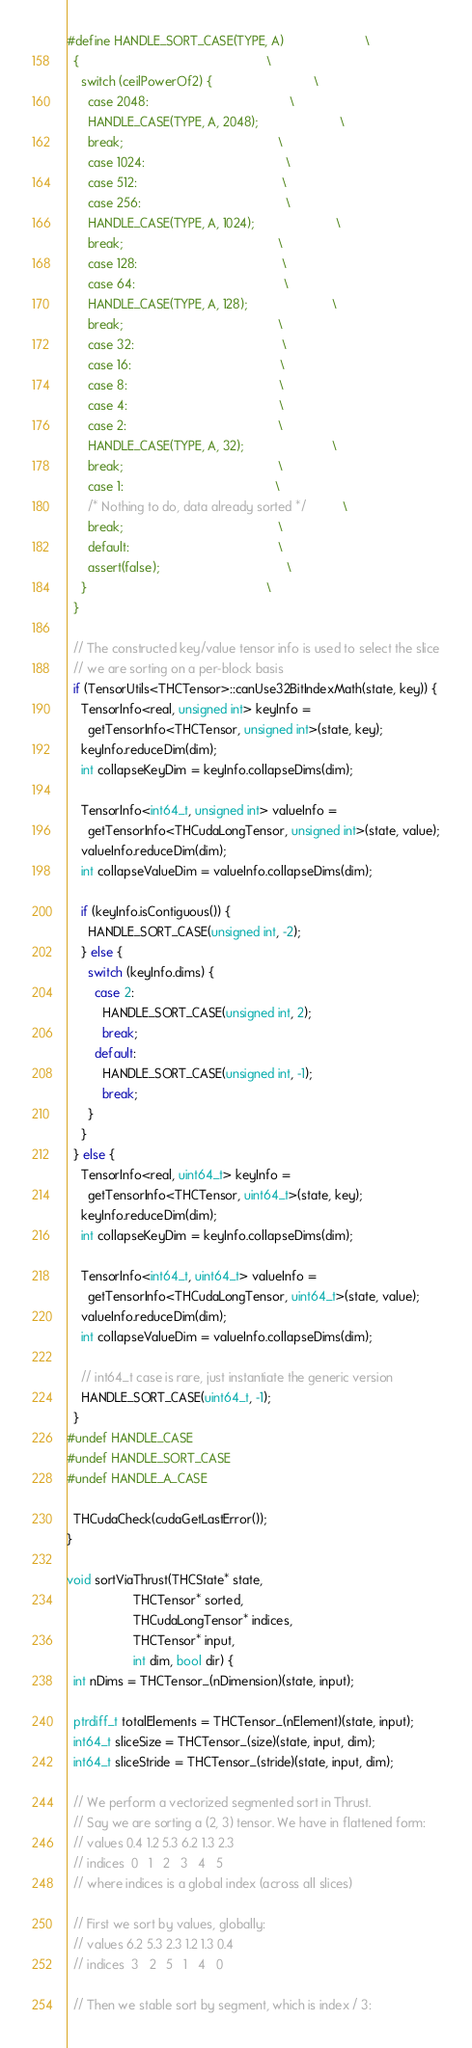Convert code to text. <code><loc_0><loc_0><loc_500><loc_500><_Cuda_>#define HANDLE_SORT_CASE(TYPE, A)                       \
  {                                                     \
    switch (ceilPowerOf2) {                             \
      case 2048:                                        \
      HANDLE_CASE(TYPE, A, 2048);                       \
      break;                                            \
      case 1024:                                        \
      case 512:                                         \
      case 256:                                         \
      HANDLE_CASE(TYPE, A, 1024);                       \
      break;                                            \
      case 128:                                         \
      case 64:                                          \
      HANDLE_CASE(TYPE, A, 128);                        \
      break;                                            \
      case 32:                                          \
      case 16:                                          \
      case 8:                                           \
      case 4:                                           \
      case 2:                                           \
      HANDLE_CASE(TYPE, A, 32);                         \
      break;                                            \
      case 1:                                           \
      /* Nothing to do, data already sorted */          \
      break;                                            \
      default:                                          \
      assert(false);                                    \
    }                                                   \
  }

  // The constructed key/value tensor info is used to select the slice
  // we are sorting on a per-block basis
  if (TensorUtils<THCTensor>::canUse32BitIndexMath(state, key)) {
    TensorInfo<real, unsigned int> keyInfo =
      getTensorInfo<THCTensor, unsigned int>(state, key);
    keyInfo.reduceDim(dim);
    int collapseKeyDim = keyInfo.collapseDims(dim);

    TensorInfo<int64_t, unsigned int> valueInfo =
      getTensorInfo<THCudaLongTensor, unsigned int>(state, value);
    valueInfo.reduceDim(dim);
    int collapseValueDim = valueInfo.collapseDims(dim);

    if (keyInfo.isContiguous()) {
      HANDLE_SORT_CASE(unsigned int, -2);
    } else {
      switch (keyInfo.dims) {
        case 2:
          HANDLE_SORT_CASE(unsigned int, 2);
          break;
        default:
          HANDLE_SORT_CASE(unsigned int, -1);
          break;
      }
    }
  } else {
    TensorInfo<real, uint64_t> keyInfo =
      getTensorInfo<THCTensor, uint64_t>(state, key);
    keyInfo.reduceDim(dim);
    int collapseKeyDim = keyInfo.collapseDims(dim);

    TensorInfo<int64_t, uint64_t> valueInfo =
      getTensorInfo<THCudaLongTensor, uint64_t>(state, value);
    valueInfo.reduceDim(dim);
    int collapseValueDim = valueInfo.collapseDims(dim);

    // int64_t case is rare, just instantiate the generic version
    HANDLE_SORT_CASE(uint64_t, -1);
  }
#undef HANDLE_CASE
#undef HANDLE_SORT_CASE
#undef HANDLE_A_CASE

  THCudaCheck(cudaGetLastError());
}

void sortViaThrust(THCState* state,
                   THCTensor* sorted,
                   THCudaLongTensor* indices,
                   THCTensor* input,
                   int dim, bool dir) {
  int nDims = THCTensor_(nDimension)(state, input);

  ptrdiff_t totalElements = THCTensor_(nElement)(state, input);
  int64_t sliceSize = THCTensor_(size)(state, input, dim);
  int64_t sliceStride = THCTensor_(stride)(state, input, dim);

  // We perform a vectorized segmented sort in Thrust.
  // Say we are sorting a (2, 3) tensor. We have in flattened form:
  // values 0.4 1.2 5.3 6.2 1.3 2.3
  // indices  0   1   2   3   4   5
  // where indices is a global index (across all slices)

  // First we sort by values, globally:
  // values 6.2 5.3 2.3 1.2 1.3 0.4
  // indices  3   2   5   1   4   0

  // Then we stable sort by segment, which is index / 3:</code> 